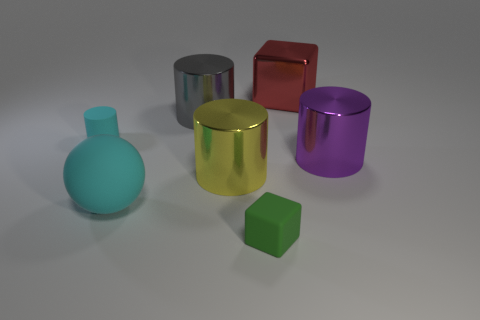Subtract 1 cylinders. How many cylinders are left? 3 Subtract all small cyan rubber cylinders. How many cylinders are left? 3 Subtract all yellow cylinders. How many cylinders are left? 3 Subtract all brown cylinders. Subtract all green balls. How many cylinders are left? 4 Add 2 red metallic things. How many objects exist? 9 Subtract all balls. How many objects are left? 6 Subtract 1 red blocks. How many objects are left? 6 Subtract all big red cylinders. Subtract all gray metal cylinders. How many objects are left? 6 Add 6 tiny blocks. How many tiny blocks are left? 7 Add 6 tiny blue cylinders. How many tiny blue cylinders exist? 6 